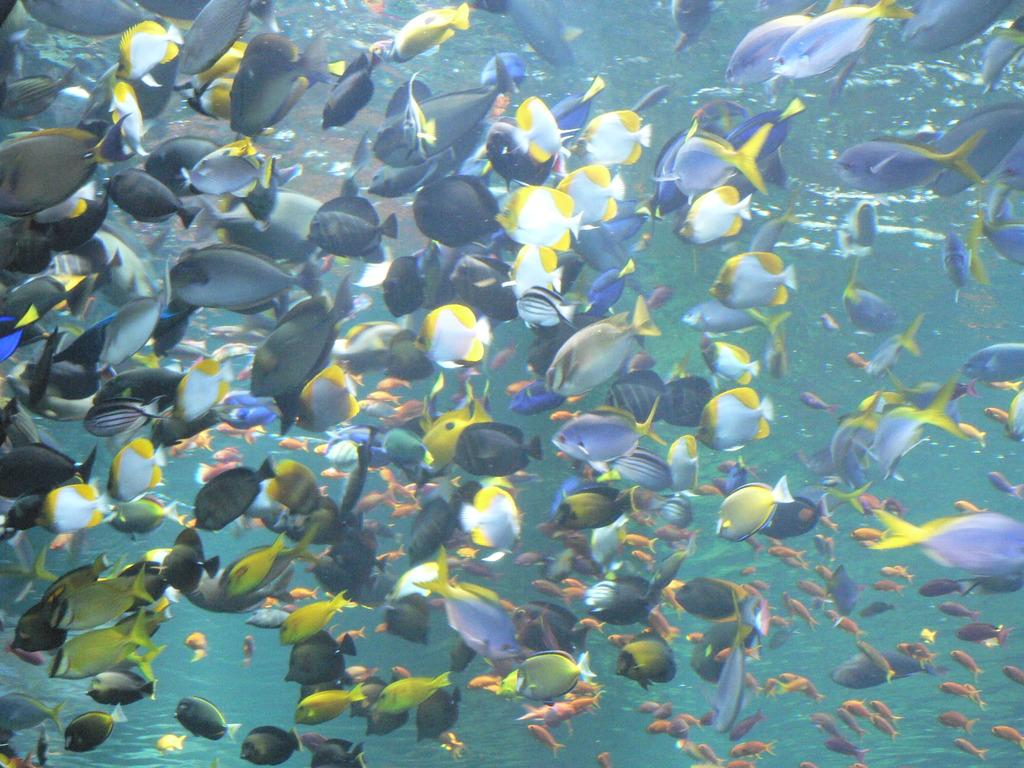What is the main subject of the image? There is a shoal of fishes in the image. What color is the water in the image? The water is off blue in color. Where was the image taken? The image was taken in the ocean. What type of education can be seen in the image? There is no education present in the image; it features a shoal of fishes in off blue water. 